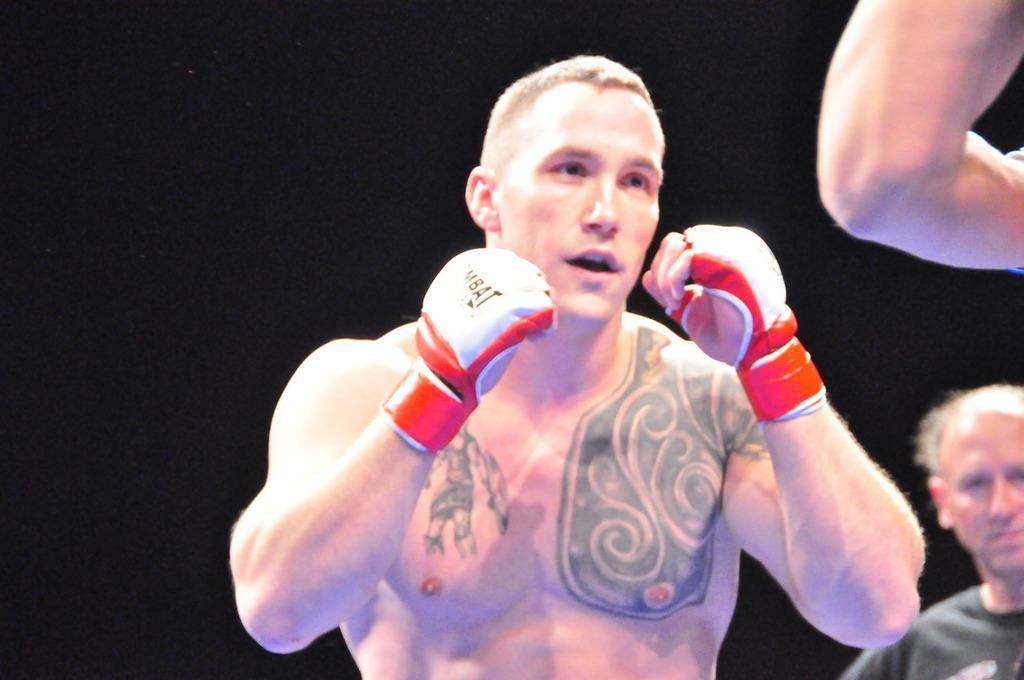Please provide a concise description of this image. In this picture I can see few people are standing and I can see a man wore gloves to his hands and looks like he is ready for boxing and I can see dark background. 